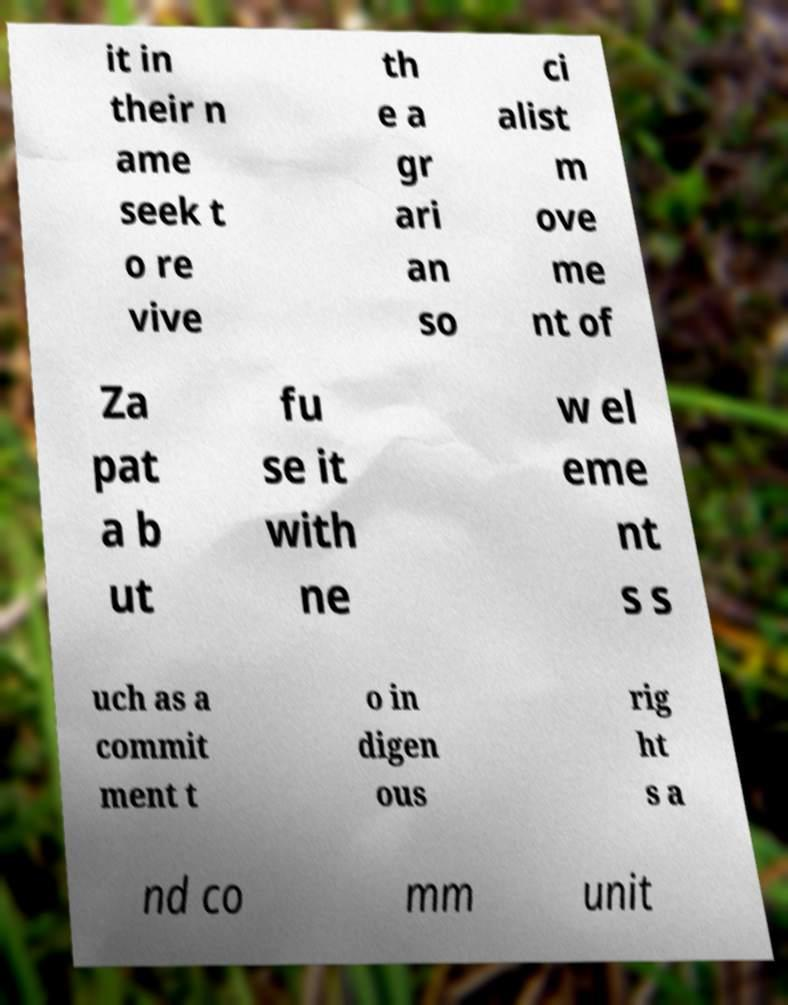Please identify and transcribe the text found in this image. it in their n ame seek t o re vive th e a gr ari an so ci alist m ove me nt of Za pat a b ut fu se it with ne w el eme nt s s uch as a commit ment t o in digen ous rig ht s a nd co mm unit 